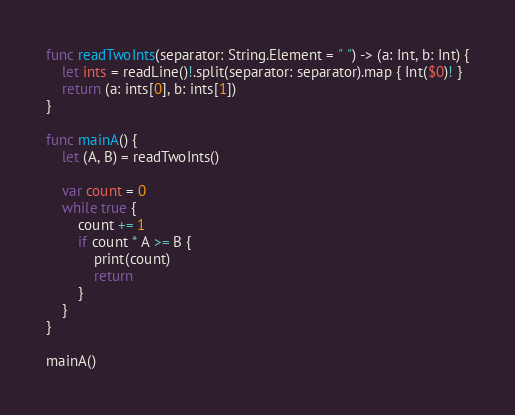Convert code to text. <code><loc_0><loc_0><loc_500><loc_500><_Swift_>func readTwoInts(separator: String.Element = " ") -> (a: Int, b: Int) {
    let ints = readLine()!.split(separator: separator).map { Int($0)! }
    return (a: ints[0], b: ints[1])
}

func mainA() {
    let (A, B) = readTwoInts()

    var count = 0
    while true {
        count += 1
        if count * A >= B {
            print(count)
            return
        }
    }
}

mainA()</code> 